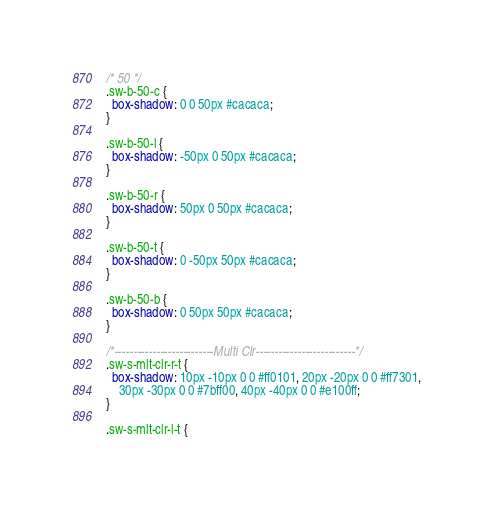Convert code to text. <code><loc_0><loc_0><loc_500><loc_500><_CSS_>
/* 50 */
.sw-b-50-c {
  box-shadow: 0 0 50px #cacaca;
}

.sw-b-50-l {
  box-shadow: -50px 0 50px #cacaca;
}

.sw-b-50-r {
  box-shadow: 50px 0 50px #cacaca;
}

.sw-b-50-t {
  box-shadow: 0 -50px 50px #cacaca;
}

.sw-b-50-b {
  box-shadow: 0 50px 50px #cacaca;
}

/*--------------------------Multi Clr--------------------------*/
.sw-s-mlt-clr-r-t {
  box-shadow: 10px -10px 0 0 #ff0101, 20px -20px 0 0 #ff7301,
    30px -30px 0 0 #7bff00, 40px -40px 0 0 #e100ff;
}

.sw-s-mlt-clr-l-t {</code> 